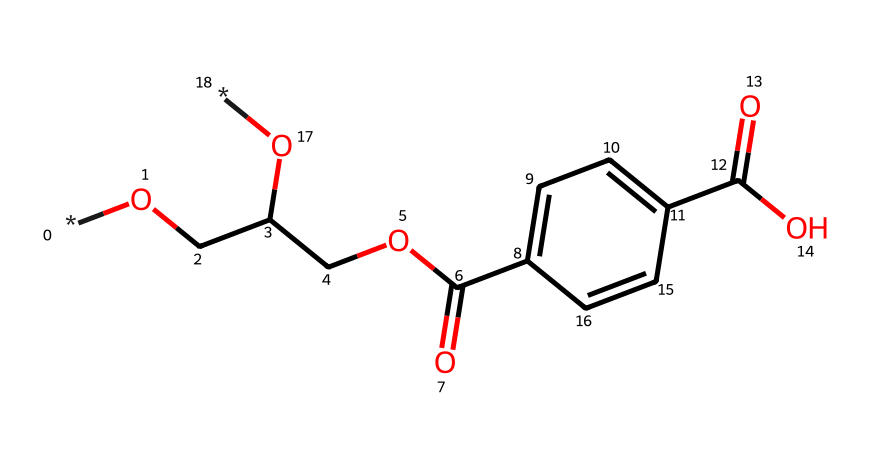What is the main type of polymer in this structure? The structure contains ester functional groups, which are characteristic of polyesters. Since the repeating units derived from terephthalic acid and ethylene glycol form polyethylene terephthalate, the main type of polymer is polyester.
Answer: polyester How many carbon atoms are present in the chemical structure? By examining the SMILES representation, I can identify a total of 10 carbon atoms throughout the structure when counting each 'C' in the skeletal formula.
Answer: 10 What kind of bonding is primarily present in polyethylene terephthalate? The main type of bonding present in polyethylene terephthalate is covalent bonding, which forms the polymer chain through the linkage of its repeating units.
Answer: covalent Does this polymer have any functional groups? Yes, the chemical contains hydroxyl (-OH) and carboxylic acid (-COOH) functional groups. These groups impart some chemical reactivity and influence the interaction of the polymer with other substances.
Answer: yes What is one major application of polyethylene terephthalate? Polyethylene terephthalate is primarily used to manufacture bottles for beverages, including office water bottles, due to its durability and transparency.
Answer: bottles In terms of thermal properties, is polyethylene terephthalate generally heat-resistant? Yes, polyethylene terephthalate has a significant heat resistance, typically remaining stable at temperatures up to 75 degrees Celsius.
Answer: yes 